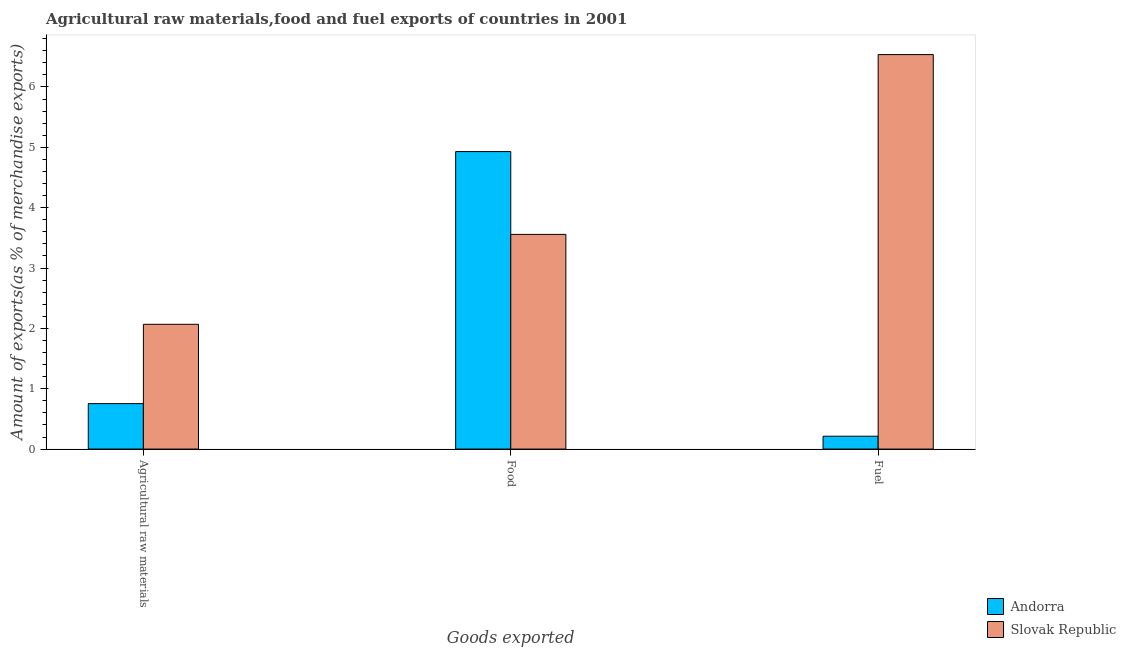How many different coloured bars are there?
Your answer should be compact. 2. Are the number of bars per tick equal to the number of legend labels?
Ensure brevity in your answer.  Yes. Are the number of bars on each tick of the X-axis equal?
Your response must be concise. Yes. What is the label of the 1st group of bars from the left?
Your answer should be very brief. Agricultural raw materials. What is the percentage of fuel exports in Slovak Republic?
Offer a terse response. 6.54. Across all countries, what is the maximum percentage of fuel exports?
Your answer should be very brief. 6.54. Across all countries, what is the minimum percentage of food exports?
Your answer should be very brief. 3.56. In which country was the percentage of raw materials exports maximum?
Your answer should be compact. Slovak Republic. In which country was the percentage of raw materials exports minimum?
Offer a very short reply. Andorra. What is the total percentage of food exports in the graph?
Make the answer very short. 8.49. What is the difference between the percentage of food exports in Andorra and that in Slovak Republic?
Your answer should be compact. 1.37. What is the difference between the percentage of raw materials exports in Slovak Republic and the percentage of fuel exports in Andorra?
Provide a short and direct response. 1.85. What is the average percentage of raw materials exports per country?
Ensure brevity in your answer.  1.41. What is the difference between the percentage of raw materials exports and percentage of food exports in Slovak Republic?
Provide a succinct answer. -1.49. In how many countries, is the percentage of fuel exports greater than 3.2 %?
Your answer should be very brief. 1. What is the ratio of the percentage of food exports in Slovak Republic to that in Andorra?
Offer a terse response. 0.72. Is the percentage of raw materials exports in Slovak Republic less than that in Andorra?
Offer a terse response. No. What is the difference between the highest and the second highest percentage of food exports?
Give a very brief answer. 1.37. What is the difference between the highest and the lowest percentage of raw materials exports?
Keep it short and to the point. 1.31. What does the 1st bar from the left in Agricultural raw materials represents?
Provide a short and direct response. Andorra. What does the 1st bar from the right in Agricultural raw materials represents?
Make the answer very short. Slovak Republic. How many bars are there?
Make the answer very short. 6. Are all the bars in the graph horizontal?
Provide a succinct answer. No. Are the values on the major ticks of Y-axis written in scientific E-notation?
Provide a succinct answer. No. Does the graph contain grids?
Your answer should be compact. No. Where does the legend appear in the graph?
Provide a succinct answer. Bottom right. What is the title of the graph?
Your answer should be compact. Agricultural raw materials,food and fuel exports of countries in 2001. Does "Sierra Leone" appear as one of the legend labels in the graph?
Your response must be concise. No. What is the label or title of the X-axis?
Give a very brief answer. Goods exported. What is the label or title of the Y-axis?
Your answer should be very brief. Amount of exports(as % of merchandise exports). What is the Amount of exports(as % of merchandise exports) in Andorra in Agricultural raw materials?
Provide a succinct answer. 0.75. What is the Amount of exports(as % of merchandise exports) in Slovak Republic in Agricultural raw materials?
Your answer should be very brief. 2.07. What is the Amount of exports(as % of merchandise exports) in Andorra in Food?
Provide a short and direct response. 4.93. What is the Amount of exports(as % of merchandise exports) in Slovak Republic in Food?
Offer a terse response. 3.56. What is the Amount of exports(as % of merchandise exports) of Andorra in Fuel?
Your answer should be very brief. 0.21. What is the Amount of exports(as % of merchandise exports) of Slovak Republic in Fuel?
Offer a terse response. 6.54. Across all Goods exported, what is the maximum Amount of exports(as % of merchandise exports) in Andorra?
Give a very brief answer. 4.93. Across all Goods exported, what is the maximum Amount of exports(as % of merchandise exports) of Slovak Republic?
Provide a short and direct response. 6.54. Across all Goods exported, what is the minimum Amount of exports(as % of merchandise exports) in Andorra?
Make the answer very short. 0.21. Across all Goods exported, what is the minimum Amount of exports(as % of merchandise exports) of Slovak Republic?
Provide a short and direct response. 2.07. What is the total Amount of exports(as % of merchandise exports) of Andorra in the graph?
Provide a succinct answer. 5.9. What is the total Amount of exports(as % of merchandise exports) in Slovak Republic in the graph?
Give a very brief answer. 12.16. What is the difference between the Amount of exports(as % of merchandise exports) of Andorra in Agricultural raw materials and that in Food?
Ensure brevity in your answer.  -4.18. What is the difference between the Amount of exports(as % of merchandise exports) in Slovak Republic in Agricultural raw materials and that in Food?
Offer a very short reply. -1.49. What is the difference between the Amount of exports(as % of merchandise exports) of Andorra in Agricultural raw materials and that in Fuel?
Your answer should be compact. 0.54. What is the difference between the Amount of exports(as % of merchandise exports) of Slovak Republic in Agricultural raw materials and that in Fuel?
Keep it short and to the point. -4.47. What is the difference between the Amount of exports(as % of merchandise exports) in Andorra in Food and that in Fuel?
Provide a succinct answer. 4.72. What is the difference between the Amount of exports(as % of merchandise exports) in Slovak Republic in Food and that in Fuel?
Your response must be concise. -2.98. What is the difference between the Amount of exports(as % of merchandise exports) of Andorra in Agricultural raw materials and the Amount of exports(as % of merchandise exports) of Slovak Republic in Food?
Ensure brevity in your answer.  -2.8. What is the difference between the Amount of exports(as % of merchandise exports) in Andorra in Agricultural raw materials and the Amount of exports(as % of merchandise exports) in Slovak Republic in Fuel?
Offer a terse response. -5.78. What is the difference between the Amount of exports(as % of merchandise exports) of Andorra in Food and the Amount of exports(as % of merchandise exports) of Slovak Republic in Fuel?
Give a very brief answer. -1.61. What is the average Amount of exports(as % of merchandise exports) of Andorra per Goods exported?
Give a very brief answer. 1.97. What is the average Amount of exports(as % of merchandise exports) in Slovak Republic per Goods exported?
Offer a very short reply. 4.05. What is the difference between the Amount of exports(as % of merchandise exports) of Andorra and Amount of exports(as % of merchandise exports) of Slovak Republic in Agricultural raw materials?
Offer a terse response. -1.31. What is the difference between the Amount of exports(as % of merchandise exports) of Andorra and Amount of exports(as % of merchandise exports) of Slovak Republic in Food?
Offer a very short reply. 1.37. What is the difference between the Amount of exports(as % of merchandise exports) in Andorra and Amount of exports(as % of merchandise exports) in Slovak Republic in Fuel?
Your answer should be compact. -6.32. What is the ratio of the Amount of exports(as % of merchandise exports) of Andorra in Agricultural raw materials to that in Food?
Offer a very short reply. 0.15. What is the ratio of the Amount of exports(as % of merchandise exports) in Slovak Republic in Agricultural raw materials to that in Food?
Make the answer very short. 0.58. What is the ratio of the Amount of exports(as % of merchandise exports) in Andorra in Agricultural raw materials to that in Fuel?
Offer a terse response. 3.53. What is the ratio of the Amount of exports(as % of merchandise exports) in Slovak Republic in Agricultural raw materials to that in Fuel?
Make the answer very short. 0.32. What is the ratio of the Amount of exports(as % of merchandise exports) in Andorra in Food to that in Fuel?
Keep it short and to the point. 23.12. What is the ratio of the Amount of exports(as % of merchandise exports) in Slovak Republic in Food to that in Fuel?
Ensure brevity in your answer.  0.54. What is the difference between the highest and the second highest Amount of exports(as % of merchandise exports) of Andorra?
Your answer should be very brief. 4.18. What is the difference between the highest and the second highest Amount of exports(as % of merchandise exports) in Slovak Republic?
Give a very brief answer. 2.98. What is the difference between the highest and the lowest Amount of exports(as % of merchandise exports) of Andorra?
Offer a very short reply. 4.72. What is the difference between the highest and the lowest Amount of exports(as % of merchandise exports) in Slovak Republic?
Your response must be concise. 4.47. 